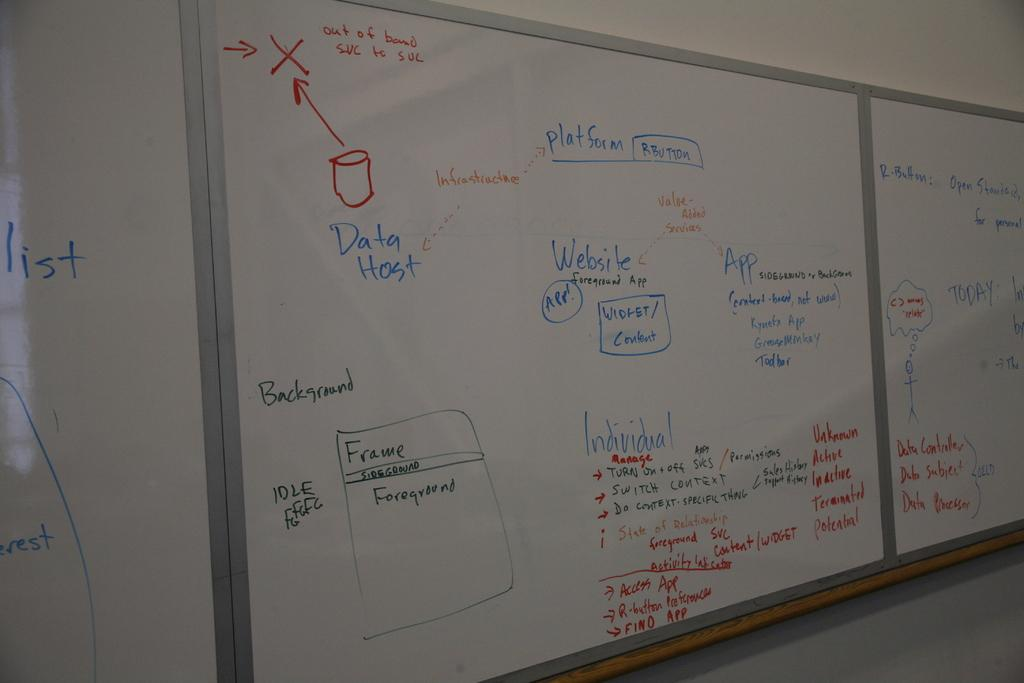What type of surface is visible on the wall in the image? There are many white classroom boards on the wall in the image. What is written on the boards? There is writing on the boards. What type of soup is being served in the image? There is no soup present in the image; it features many white classroom boards on the wall with writing on them. How many spiders can be seen crawling on the boards in the image? There are no spiders present in the image; it only features white classroom boards with writing on them. 